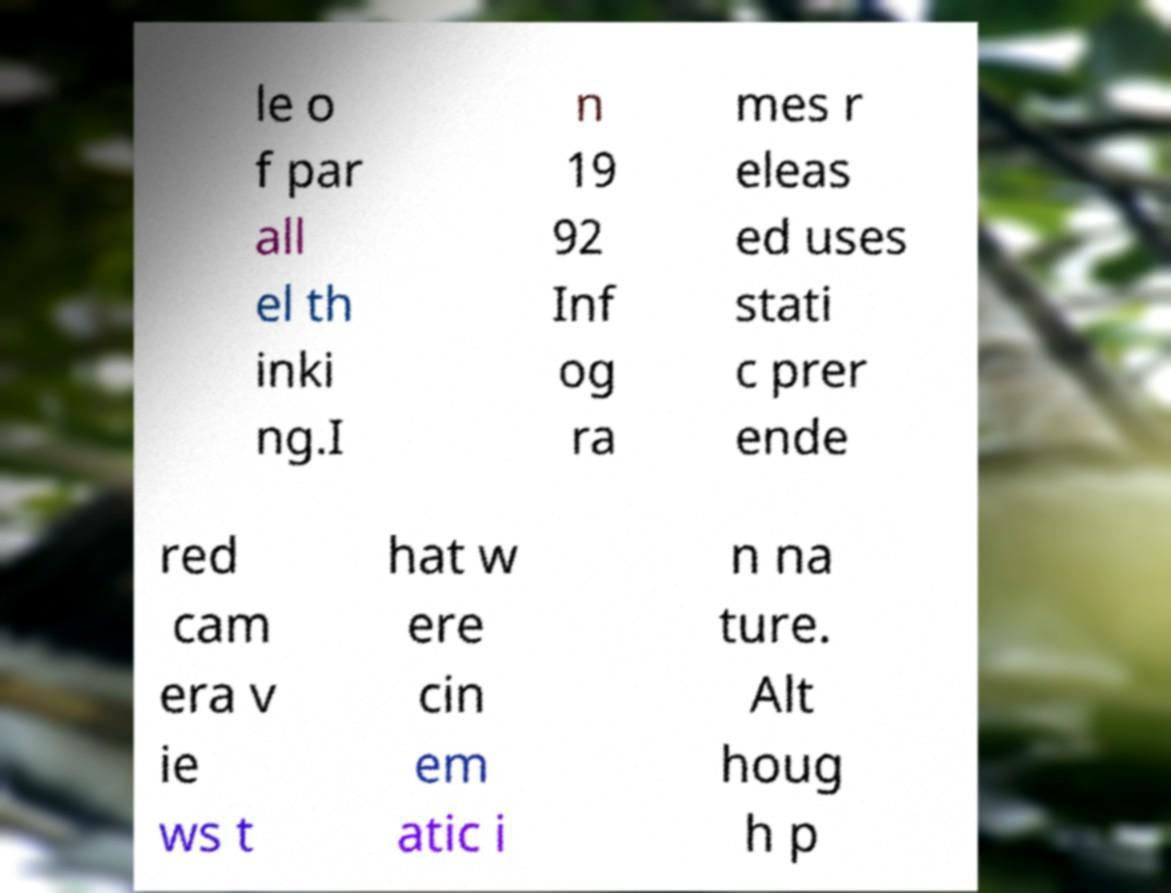Please identify and transcribe the text found in this image. le o f par all el th inki ng.I n 19 92 Inf og ra mes r eleas ed uses stati c prer ende red cam era v ie ws t hat w ere cin em atic i n na ture. Alt houg h p 